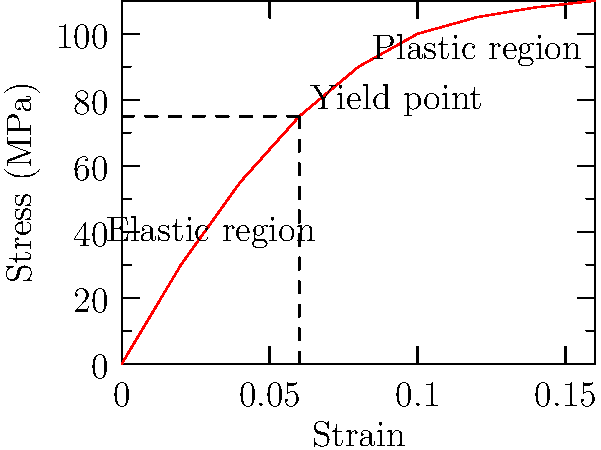Based on the stress-strain curve for wood fibers in a tree trunk, explain how the biomechanical properties of wood contribute to a tree's ability to withstand environmental stresses. How might this knowledge inform pruning practices to maintain structural integrity? To answer this question, let's analyze the stress-strain curve and its implications for tree biomechanics:

1. Elastic region:
   - In the initial part of the curve, stress increases linearly with strain.
   - This represents the tree's ability to bend and return to its original shape under normal conditions.
   - The slope of this region is the Young's modulus (E), indicating the stiffness of the wood.

2. Yield point:
   - The point where the curve begins to deviate from linearity.
   - Represents the maximum stress the wood can withstand before permanent deformation occurs.

3. Plastic region:
   - Beyond the yield point, the wood undergoes permanent deformation.
   - The curve flattens, showing that less additional stress is required for further strain.

4. Implications for tree biomechanics:
   - Trees have evolved to operate primarily in the elastic region, allowing them to bend in wind and return to their original shape.
   - The yield point represents the tree's safety limit for environmental stresses.
   - The plastic region indicates potential failure points in extreme conditions.

5. Application to pruning practices:
   - Pruning should aim to maintain a balance that keeps the tree operating within its elastic region.
   - Removing excess weight from branches can reduce stress on the trunk and main limbs.
   - Proper pruning can help distribute stress more evenly throughout the tree structure.

6. Structural integrity considerations:
   - Understanding the stress-strain relationship helps in identifying potential weak points in the tree.
   - Pruning can be targeted to reduce stress on areas approaching their yield point.
   - Regular maintenance based on this biomechanical knowledge can prevent catastrophic failures.

7. Long-term tree health:
   - By keeping the tree's stress levels within the elastic region, pruning practices can promote healthy growth and longevity.
   - This approach aligns with the persona's appreciation for quality work and safety in tree care.
Answer: Pruning based on wood's stress-strain properties maintains tree structure within its elastic limit, preventing permanent deformation and failure while promoting long-term health and safety. 